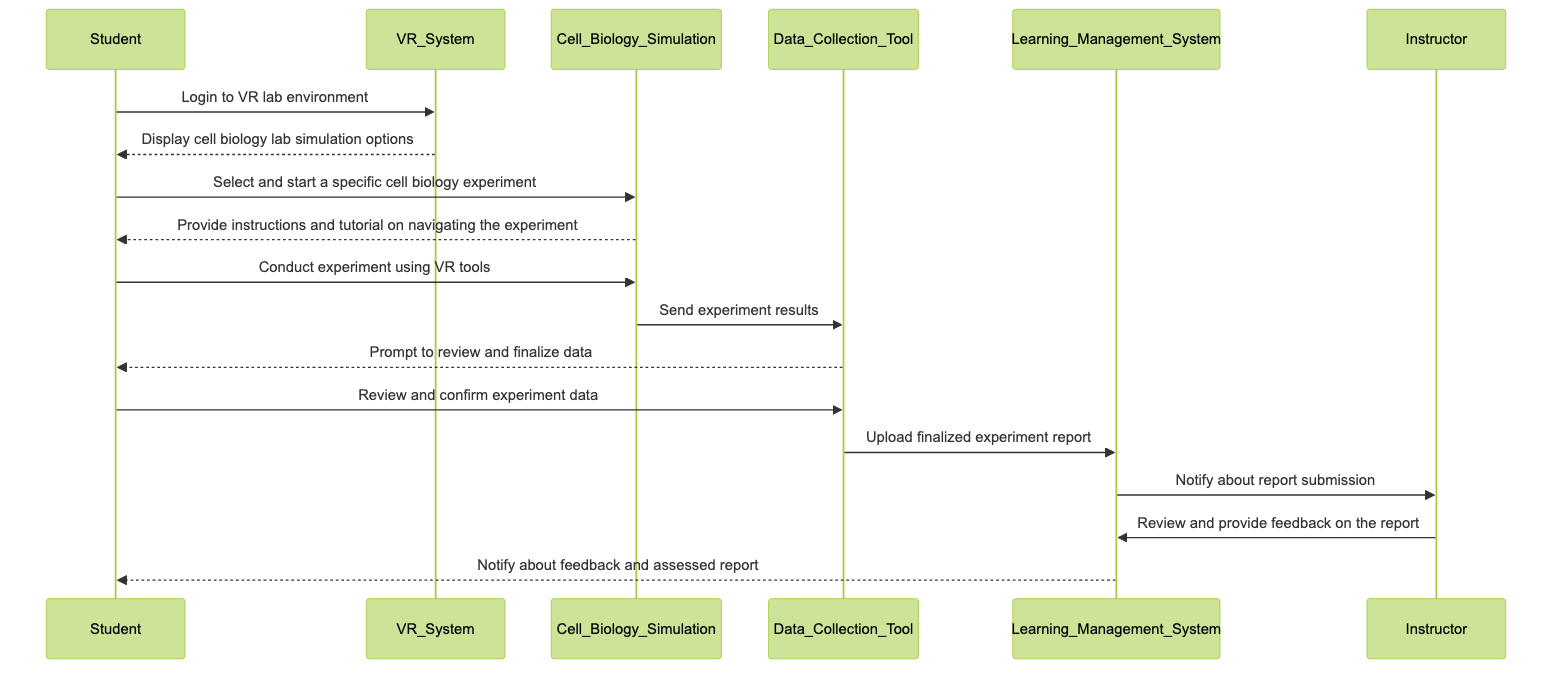What is the first action performed by the student? The first action performed by the student in the diagram is to log in to the VR lab environment. This is observed in the initial interaction where the "Student" actor initiates the sequence by sending a message to the "VR_System" stating "Login to VR lab environment."
Answer: Login to VR lab environment How many actors are involved in this sequence diagram? The diagram includes six distinct actors that are specified in the data section: Student, VR_System, Cell_Biology_Simulation, Data_Collection_Tool, Learning_Management_System, and Instructor. Counting each one leads to a total of six actors.
Answer: Six What tool is used to collect experiment data? The tool responsible for collecting experiment data in the diagram is referred to as the "Data_Collection_Tool." This actor is specifically mentioned as integrated within the VR system for recording and reporting experiment results.
Answer: Data Collection Tool Which actor provides feedback on the report? The actor that provides feedback on the report in this sequence diagram is the "Instructor." The interaction shows that the instructor reviews the submitted report within the Learning Management System.
Answer: Instructor What does the student do after conducting the experiment? After conducting the experiment, the student is prompted by the Data Collection Tool to review and finalize the data. This action follows immediately after the experiment results are sent to the Data Collection Tool by the Cell Biology Simulation.
Answer: Review and finalize data Explain the process of data submission after data collection. The data submission process begins when the Cell Biology Simulation sends the experiment results to the Data Collection Tool. Then, the Data Collection Tool prompts the student to review and confirm the experiment data. Once confirmed, the Data Collection Tool uploads the finalized experiment report to the Learning Management System, which subsequently notifies the Instructor about the report submission. This sequence illustrates a clear path from data collection to report submission and notification.
Answer: Data Collection Tool uploads finalized experiment report What action follows after the instructor reviews the report? After the instructor reviews the report, the Learning Management System sends a notification back to the student about the feedback and assessed report. This interaction indicates the completion of the feedback process for the submitted assignment.
Answer: Notify about feedback and assessed report How does the student start the cell biology experiment? The student starts the cell biology experiment by selecting and starting a specific cell biology experiment from the options displayed by the VR System. This selection action occurs after the student logs into the VR lab environment and views the available simulation options.
Answer: Select and start a specific cell biology experiment 